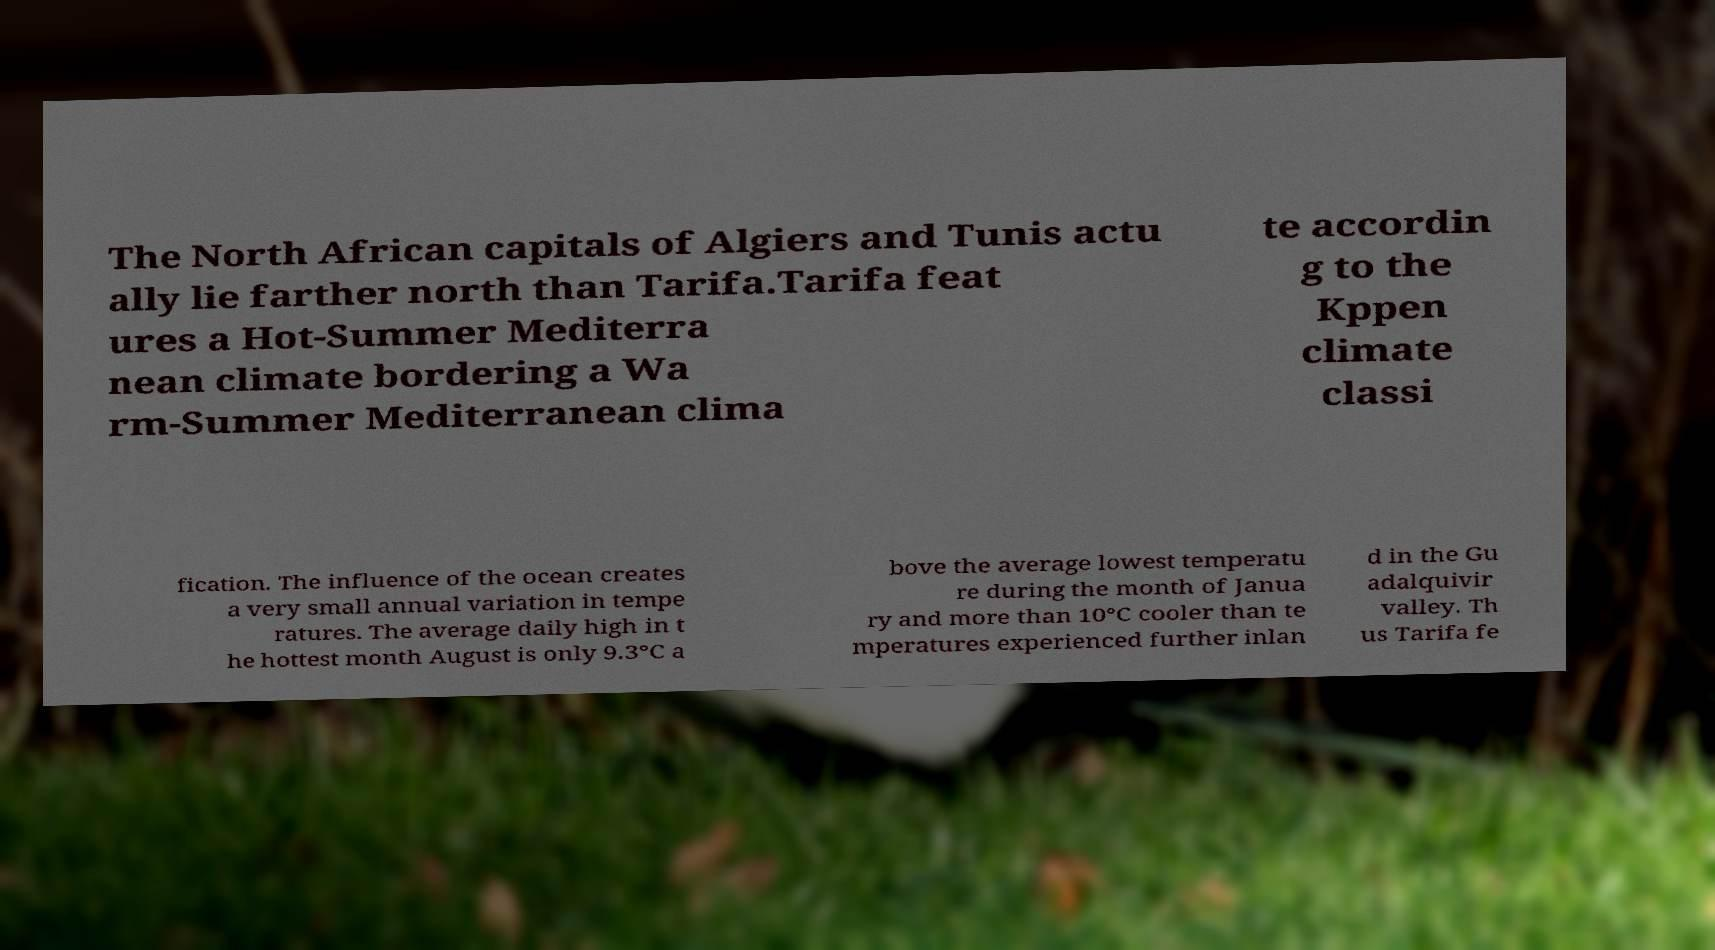Please read and relay the text visible in this image. What does it say? The North African capitals of Algiers and Tunis actu ally lie farther north than Tarifa.Tarifa feat ures a Hot-Summer Mediterra nean climate bordering a Wa rm-Summer Mediterranean clima te accordin g to the Kppen climate classi fication. The influence of the ocean creates a very small annual variation in tempe ratures. The average daily high in t he hottest month August is only 9.3°C a bove the average lowest temperatu re during the month of Janua ry and more than 10°C cooler than te mperatures experienced further inlan d in the Gu adalquivir valley. Th us Tarifa fe 